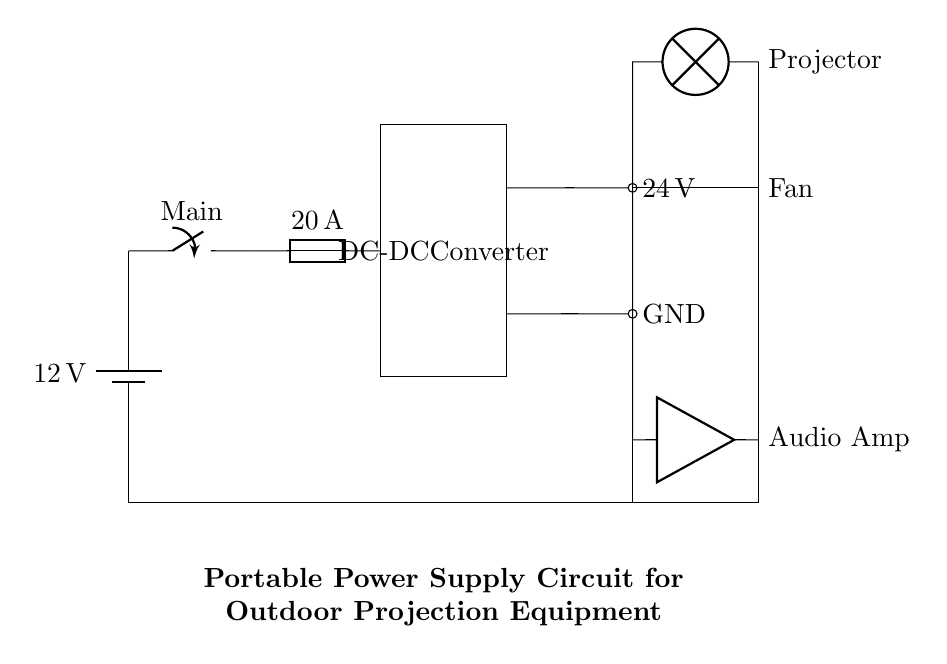What is the voltage of the power source? The circuit shows a battery labeled with a voltage of 12 volts connected to the circuit. This is the potential difference supplied by the power source.
Answer: 12 volts What is the rating of the fuse? The fuse in the circuit is labeled with a rating of 20 Amperes, which indicates the maximum current it can handle before blowing to protect the circuit from excessive current.
Answer: 20 Amperes What type of circuit component is used to convert the voltage? The circuit includes a component labeled "DC-DC Converter." This is a circuit specifically designed to convert the input DC voltage (12V) into a higher output voltage (24V).
Answer: DC-DC Converter What is the output voltage of the DC-DC Converter? The output voltage of the DC-DC Converter is indicated in the circuit diagram, where it shows an output of 24 volts. This is the voltage available for the other components after conversion.
Answer: 24 volts What is the purpose of the cooling fan in this circuit? The cooling fan is used for thermal management; it keeps the temperature of the projector and other components within safe limits, ensuring they do not overheat during operation.
Answer: Cooling Which components share a common ground? The ground connection is shown in the diagram where all the components, such as the projector, audio amplifier, and DC-DC converter, connect to the same ground point. This ensures a common reference voltage throughout the circuit.
Answer: Projector, Audio Amp, DC-DC Converter Explain the connection of the audio amplifier in the circuit. The audio amplifier is connected to the output of the cooling fan, which means it shares power from the same source. It is positioned lower in the circuit diagram and receives 24 volts. Its connection ensures that the audio equipment works simultaneously with the projector.
Answer: Connected below the fan 